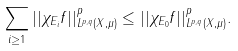Convert formula to latex. <formula><loc_0><loc_0><loc_500><loc_500>\sum _ { i \geq 1 } | | \chi _ { E _ { i } } f | | _ { L ^ { p , q } ( X , \mu ) } ^ { p } \leq | | \chi _ { E _ { 0 } } f | | _ { L ^ { p , q } ( X , \mu ) } ^ { p } .</formula> 